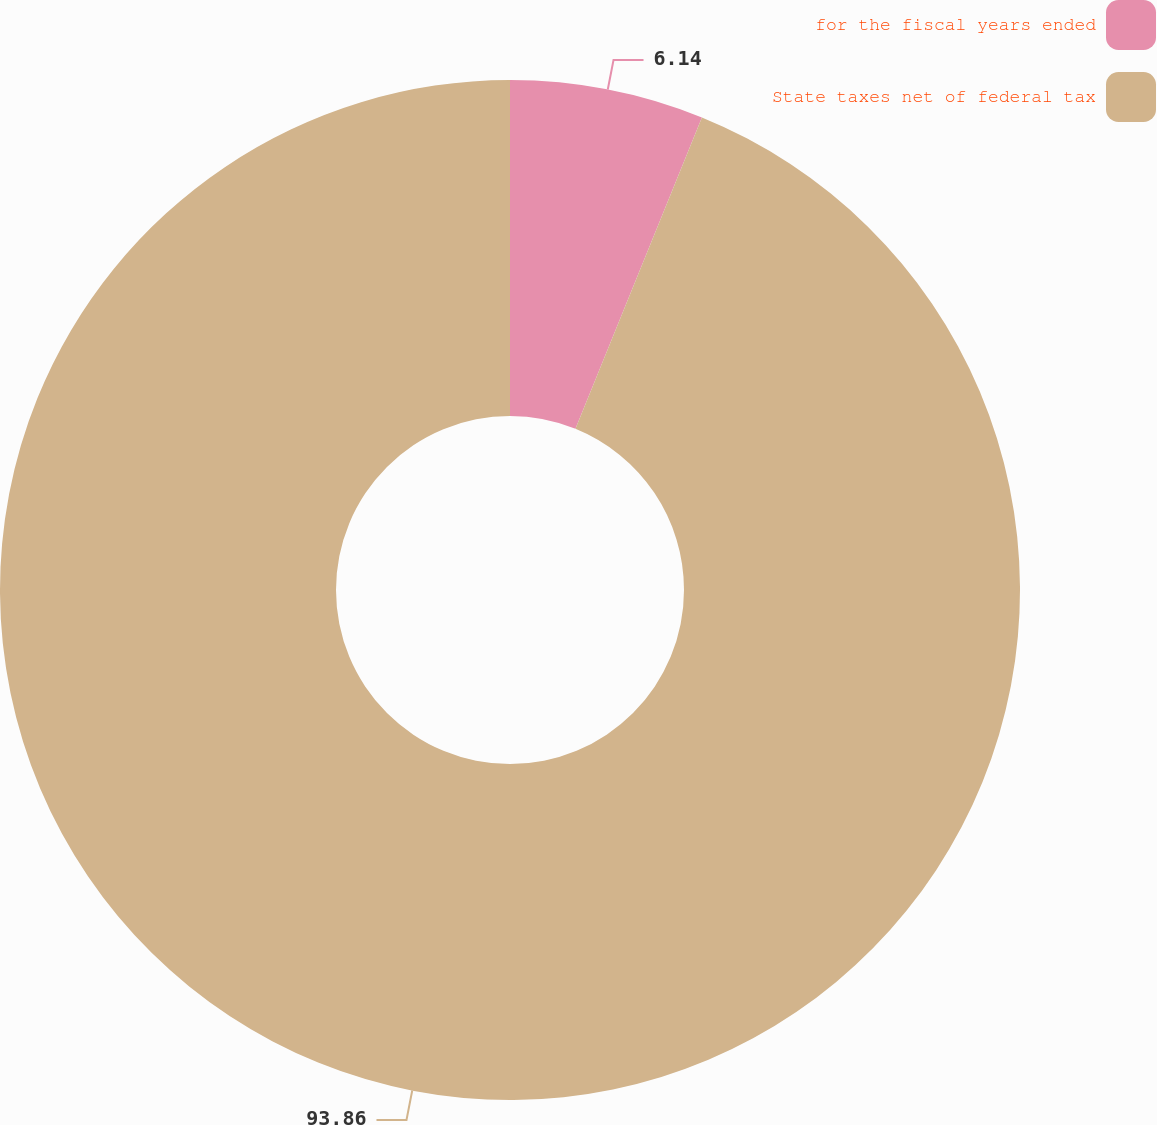<chart> <loc_0><loc_0><loc_500><loc_500><pie_chart><fcel>for the fiscal years ended<fcel>State taxes net of federal tax<nl><fcel>6.14%<fcel>93.86%<nl></chart> 